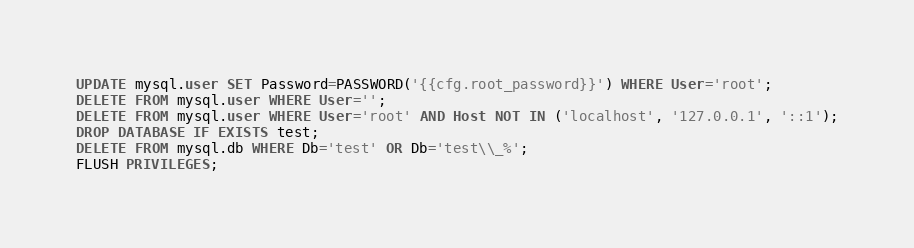<code> <loc_0><loc_0><loc_500><loc_500><_SQL_>UPDATE mysql.user SET Password=PASSWORD('{{cfg.root_password}}') WHERE User='root';
DELETE FROM mysql.user WHERE User='';
DELETE FROM mysql.user WHERE User='root' AND Host NOT IN ('localhost', '127.0.0.1', '::1');
DROP DATABASE IF EXISTS test;
DELETE FROM mysql.db WHERE Db='test' OR Db='test\\_%';
FLUSH PRIVILEGES;</code> 